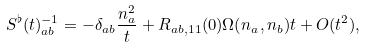<formula> <loc_0><loc_0><loc_500><loc_500>S ^ { \flat } ( t ) ^ { - 1 } _ { a b } = - \delta _ { a b } \frac { n ^ { 2 } _ { a } } { t } + R _ { a b , 1 1 } ( 0 ) \Omega ( n _ { a } , n _ { b } ) t + O ( t ^ { 2 } ) ,</formula> 